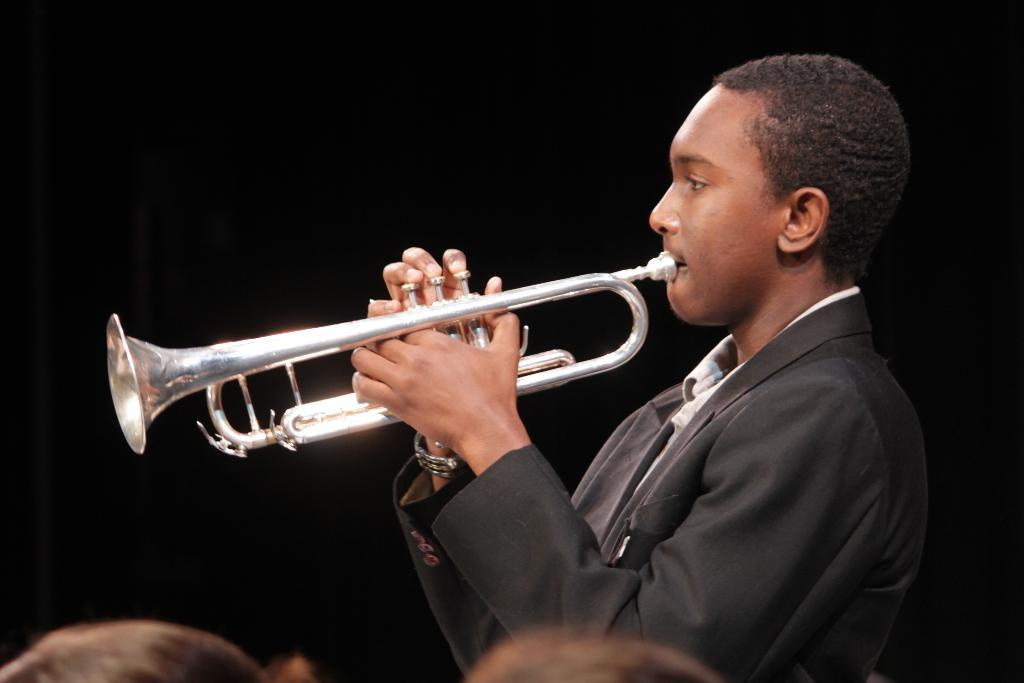What is the main subject of the image? There is a person in the image. What is the person doing in the image? The person is playing a trumpet. Can you describe the background of the image? The background of the image is dark. How many sisters does the person playing the trumpet have in the image? There is no information about the person's sisters in the image. What type of rest can be seen in the image? There is no rest or resting area visible in the image. 